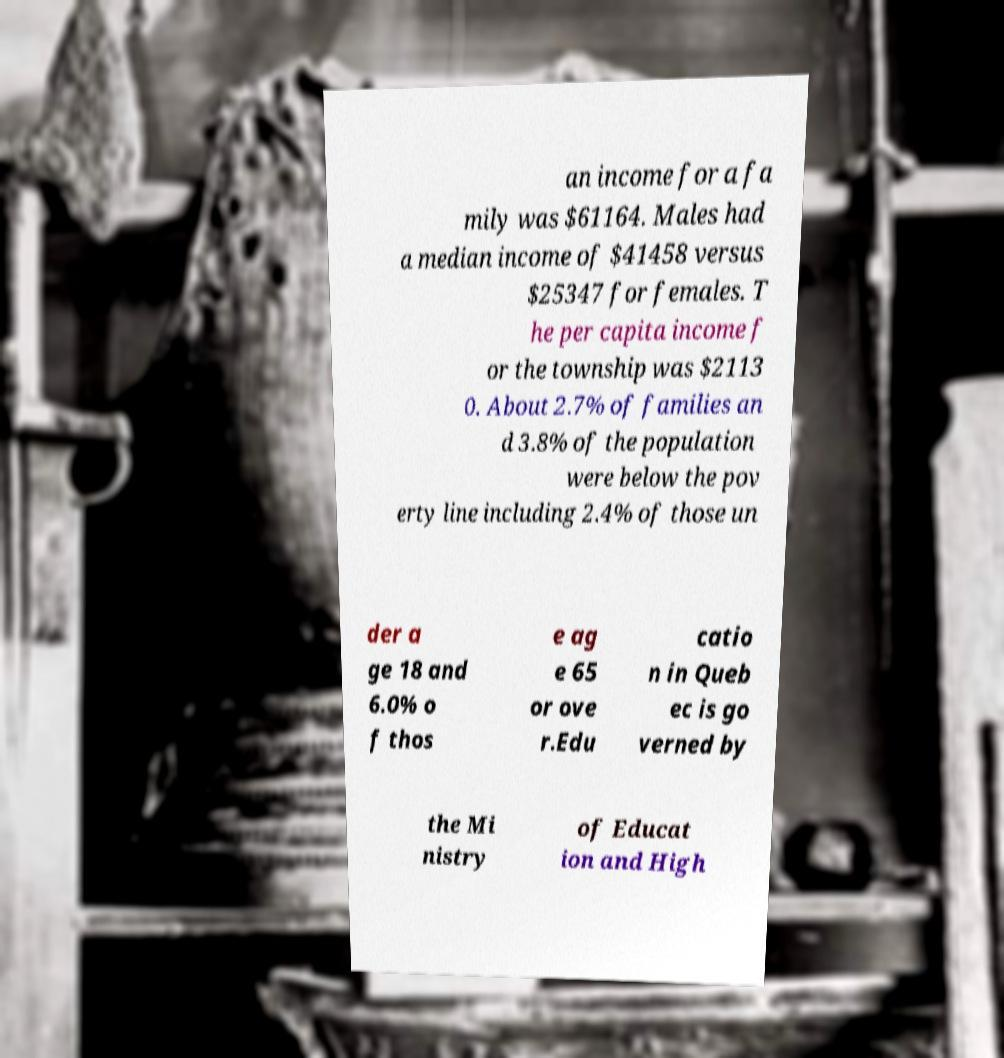Could you assist in decoding the text presented in this image and type it out clearly? an income for a fa mily was $61164. Males had a median income of $41458 versus $25347 for females. T he per capita income f or the township was $2113 0. About 2.7% of families an d 3.8% of the population were below the pov erty line including 2.4% of those un der a ge 18 and 6.0% o f thos e ag e 65 or ove r.Edu catio n in Queb ec is go verned by the Mi nistry of Educat ion and High 